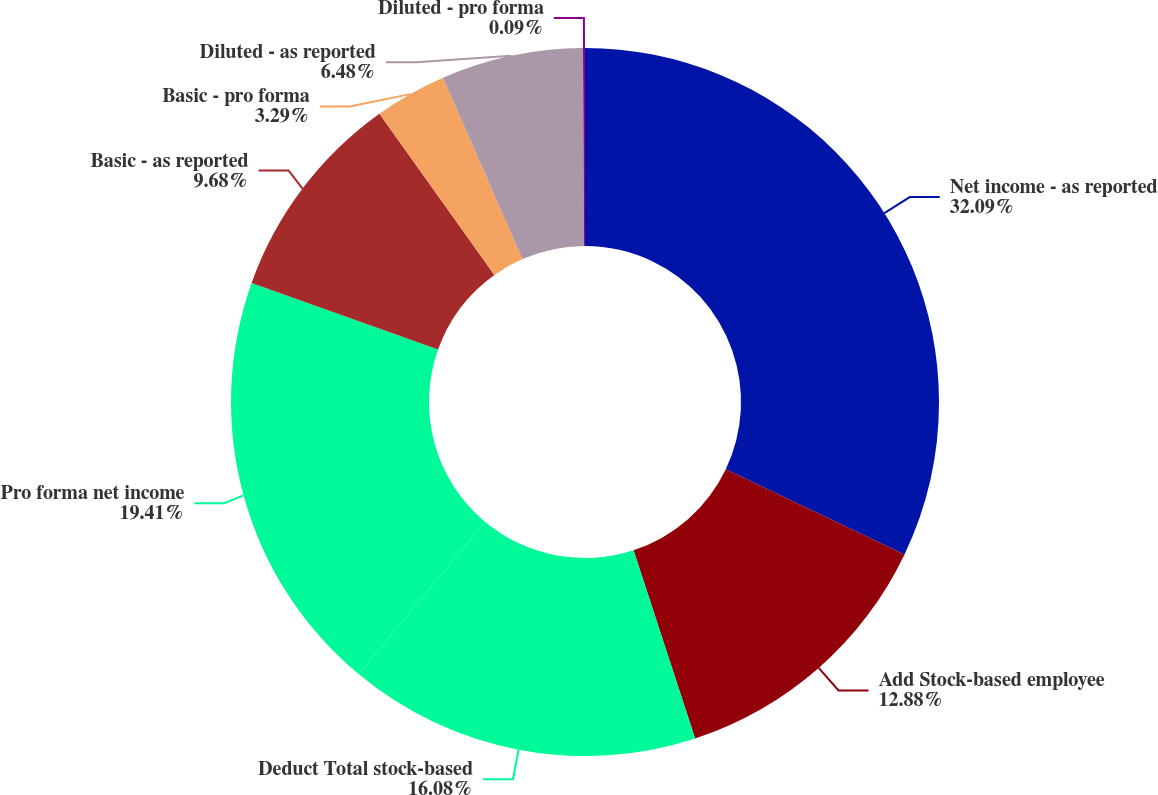Convert chart. <chart><loc_0><loc_0><loc_500><loc_500><pie_chart><fcel>Net income - as reported<fcel>Add Stock-based employee<fcel>Deduct Total stock-based<fcel>Pro forma net income<fcel>Basic - as reported<fcel>Basic - pro forma<fcel>Diluted - as reported<fcel>Diluted - pro forma<nl><fcel>32.08%<fcel>12.88%<fcel>16.08%<fcel>19.41%<fcel>9.68%<fcel>3.29%<fcel>6.48%<fcel>0.09%<nl></chart> 